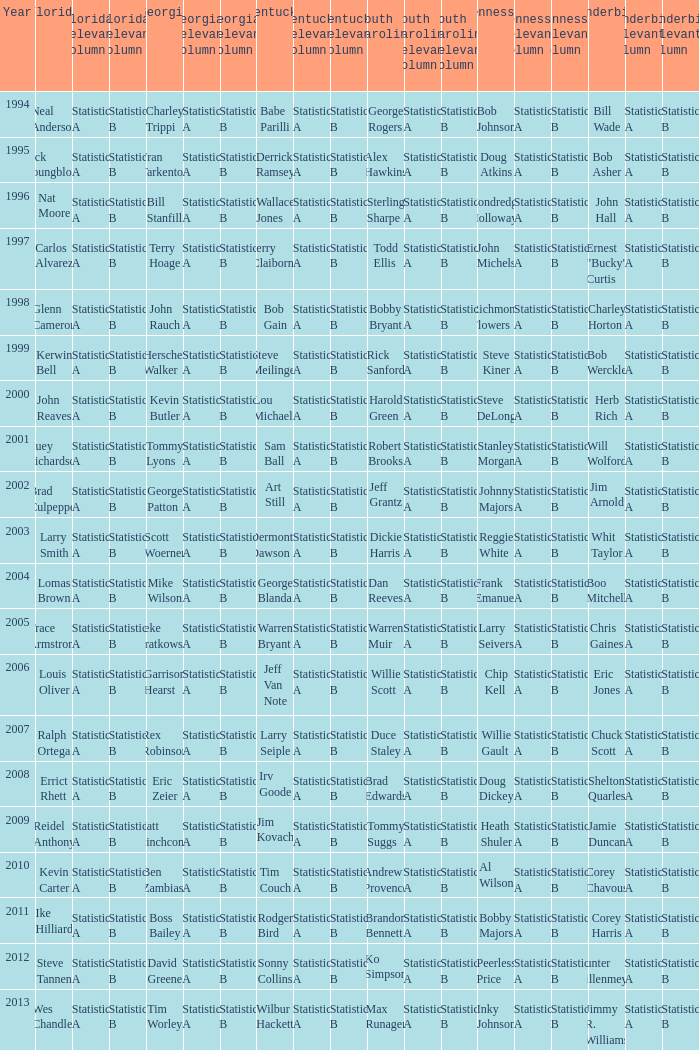I'm looking to parse the entire table for insights. Could you assist me with that? {'header': ['Year', 'Florida', 'Florida Relevant Column 1', 'Florida Relevant Column 2', 'Georgia', 'Georgia Relevant Column 1', 'Georgia Relevant Column 2', 'Kentucky', 'Kentucky Relevant Column 1', 'Kentucky Relevant Column 2', 'South Carolina', 'South Carolina Relevant Column 1', 'South Carolina Relevant Column 2', 'Tennessee', 'Tennessee Relevant Column 1', 'Tennessee Relevant Column 2', 'Vanderbilt', 'Vanderbilt Relevant Column 1', 'Vanderbilt Relevant Column 2'], 'rows': [['1994', 'Neal Anderson', 'Statistic A', 'Statistic B', 'Charley Trippi', 'Statistic A', 'Statistic B', 'Babe Parilli', 'Statistic A', 'Statistic B', 'George Rogers', 'Statistic A', 'Statistic B', 'Bob Johnson', 'Statistic A', 'Statistic B', 'Bill Wade', 'Statistic A', 'Statistic B'], ['1995', 'Jack Youngblood', 'Statistic A', 'Statistic B', 'Fran Tarkenton', 'Statistic A', 'Statistic B', 'Derrick Ramsey', 'Statistic A', 'Statistic B', 'Alex Hawkins', 'Statistic A', 'Statistic B', 'Doug Atkins', 'Statistic A', 'Statistic B', 'Bob Asher', 'Statistic A', 'Statistic B'], ['1996', 'Nat Moore', 'Statistic A', 'Statistic B', 'Bill Stanfill', 'Statistic A', 'Statistic B', 'Wallace Jones', 'Statistic A', 'Statistic B', 'Sterling Sharpe', 'Statistic A', 'Statistic B', 'Condredge Holloway', 'Statistic A', 'Statistic B', 'John Hall', 'Statistic A', 'Statistic B'], ['1997', 'Carlos Alvarez', 'Statistic A', 'Statistic B', 'Terry Hoage', 'Statistic A', 'Statistic B', 'Jerry Claiborne', 'Statistic A', 'Statistic B', 'Todd Ellis', 'Statistic A', 'Statistic B', 'John Michels', 'Statistic A', 'Statistic B', 'Ernest "Bucky" Curtis', 'Statistic A', 'Statistic B'], ['1998', 'Glenn Cameron', 'Statistic A', 'Statistic B', 'John Rauch', 'Statistic A', 'Statistic B', 'Bob Gain', 'Statistic A', 'Statistic B', 'Bobby Bryant', 'Statistic A', 'Statistic B', 'Richmond Flowers', 'Statistic A', 'Statistic B', 'Charley Horton', 'Statistic A', 'Statistic B'], ['1999', 'Kerwin Bell', 'Statistic A', 'Statistic B', 'Herschel Walker', 'Statistic A', 'Statistic B', 'Steve Meilinger', 'Statistic A', 'Statistic B', 'Rick Sanford', 'Statistic A', 'Statistic B', 'Steve Kiner', 'Statistic A', 'Statistic B', 'Bob Werckle', 'Statistic A', 'Statistic B'], ['2000', 'John Reaves', 'Statistic A', 'Statistic B', 'Kevin Butler', 'Statistic A', 'Statistic B', 'Lou Michaels', 'Statistic A', 'Statistic B', 'Harold Green', 'Statistic A', 'Statistic B', 'Steve DeLong', 'Statistic A', 'Statistic B', 'Herb Rich', 'Statistic A', 'Statistic B'], ['2001', 'Huey Richardson', 'Statistic A', 'Statistic B', 'Tommy Lyons', 'Statistic A', 'Statistic B', 'Sam Ball', 'Statistic A', 'Statistic B', 'Robert Brooks', 'Statistic A', 'Statistic B', 'Stanley Morgan', 'Statistic A', 'Statistic B', 'Will Wolford', 'Statistic A', 'Statistic B'], ['2002', 'Brad Culpepper', 'Statistic A', 'Statistic B', 'George Patton', 'Statistic A', 'Statistic B', 'Art Still', 'Statistic A', 'Statistic B', 'Jeff Grantz', 'Statistic A', 'Statistic B', 'Johnny Majors', 'Statistic A', 'Statistic B', 'Jim Arnold', 'Statistic A', 'Statistic B'], ['2003', 'Larry Smith', 'Statistic A', 'Statistic B', 'Scott Woerner', 'Statistic A', 'Statistic B', 'Dermontti Dawson', 'Statistic A', 'Statistic B', 'Dickie Harris', 'Statistic A', 'Statistic B', 'Reggie White', 'Statistic A', 'Statistic B', 'Whit Taylor', 'Statistic A', 'Statistic B'], ['2004', 'Lomas Brown', 'Statistic A', 'Statistic B', 'Mike Wilson', 'Statistic A', 'Statistic B', 'George Blanda', 'Statistic A', 'Statistic B', 'Dan Reeves', 'Statistic A', 'Statistic B', 'Frank Emanuel', 'Statistic A', 'Statistic B', 'Boo Mitchell', 'Statistic A', 'Statistic B'], ['2005', 'Trace Armstrong', 'Statistic A', 'Statistic B', 'Zeke Bratkowski', 'Statistic A', 'Statistic B', 'Warren Bryant', 'Statistic A', 'Statistic B', 'Warren Muir', 'Statistic A', 'Statistic B', 'Larry Seivers', 'Statistic A', 'Statistic B', 'Chris Gaines', 'Statistic A', 'Statistic B'], ['2006', 'Louis Oliver', 'Statistic A', 'Statistic B', 'Garrison Hearst', 'Statistic A', 'Statistic B', 'Jeff Van Note', 'Statistic A', 'Statistic B', 'Willie Scott', 'Statistic A', 'Statistic B', 'Chip Kell', 'Statistic A', 'Statistic B', 'Eric Jones', 'Statistic A', 'Statistic B'], ['2007', 'Ralph Ortega', 'Statistic A', 'Statistic B', 'Rex Robinson', 'Statistic A', 'Statistic B', 'Larry Seiple', 'Statistic A', 'Statistic B', 'Duce Staley', 'Statistic A', 'Statistic B', 'Willie Gault', 'Statistic A', 'Statistic B', 'Chuck Scott', 'Statistic A', 'Statistic B'], ['2008', 'Errict Rhett', 'Statistic A', 'Statistic B', 'Eric Zeier', 'Statistic A', 'Statistic B', 'Irv Goode', 'Statistic A', 'Statistic B', 'Brad Edwards', 'Statistic A', 'Statistic B', 'Doug Dickey', 'Statistic A', 'Statistic B', 'Shelton Quarles', 'Statistic A', 'Statistic B'], ['2009', 'Reidel Anthony', 'Statistic A', 'Statistic B', 'Matt Stinchcomb', 'Statistic A', 'Statistic B', 'Jim Kovach', 'Statistic A', 'Statistic B', 'Tommy Suggs', 'Statistic A', 'Statistic B', 'Heath Shuler', 'Statistic A', 'Statistic B', 'Jamie Duncan', 'Statistic A', 'Statistic B'], ['2010', 'Kevin Carter', 'Statistic A', 'Statistic B', 'Ben Zambiasi', 'Statistic A', 'Statistic B', 'Tim Couch', 'Statistic A', 'Statistic B', 'Andrew Provence', 'Statistic A', 'Statistic B', 'Al Wilson', 'Statistic A', 'Statistic B', 'Corey Chavous', 'Statistic A', 'Statistic B'], ['2011', 'Ike Hilliard', 'Statistic A', 'Statistic B', 'Boss Bailey', 'Statistic A', 'Statistic B', 'Rodger Bird', 'Statistic A', 'Statistic B', 'Brandon Bennett', 'Statistic A', 'Statistic B', 'Bobby Majors', 'Statistic A', 'Statistic B', 'Corey Harris', 'Statistic A', 'Statistic B'], ['2012', 'Steve Tannen', 'Statistic A', 'Statistic B', 'David Greene', 'Statistic A', 'Statistic B', 'Sonny Collins', 'Statistic A', 'Statistic B', 'Ko Simpson', 'Statistic A', 'Statistic B', 'Peerless Price', 'Statistic A', 'Statistic B', 'Hunter Hillenmeyer', 'Statistic A', 'Statistic B'], ['2013', 'Wes Chandler', 'Statistic A', 'Statistic B', 'Tim Worley', 'Statistic A', 'Statistic B', 'Wilbur Hackett', 'Statistic A', 'Statistic B', 'Max Runager', 'Statistic A', 'Statistic B', 'Inky Johnson', 'Statistic A', 'Statistic B', 'Jimmy R. Williams', 'Statistic A', 'Statistic B']]} What is the Tennessee with a Kentucky of Larry Seiple Willie Gault. 